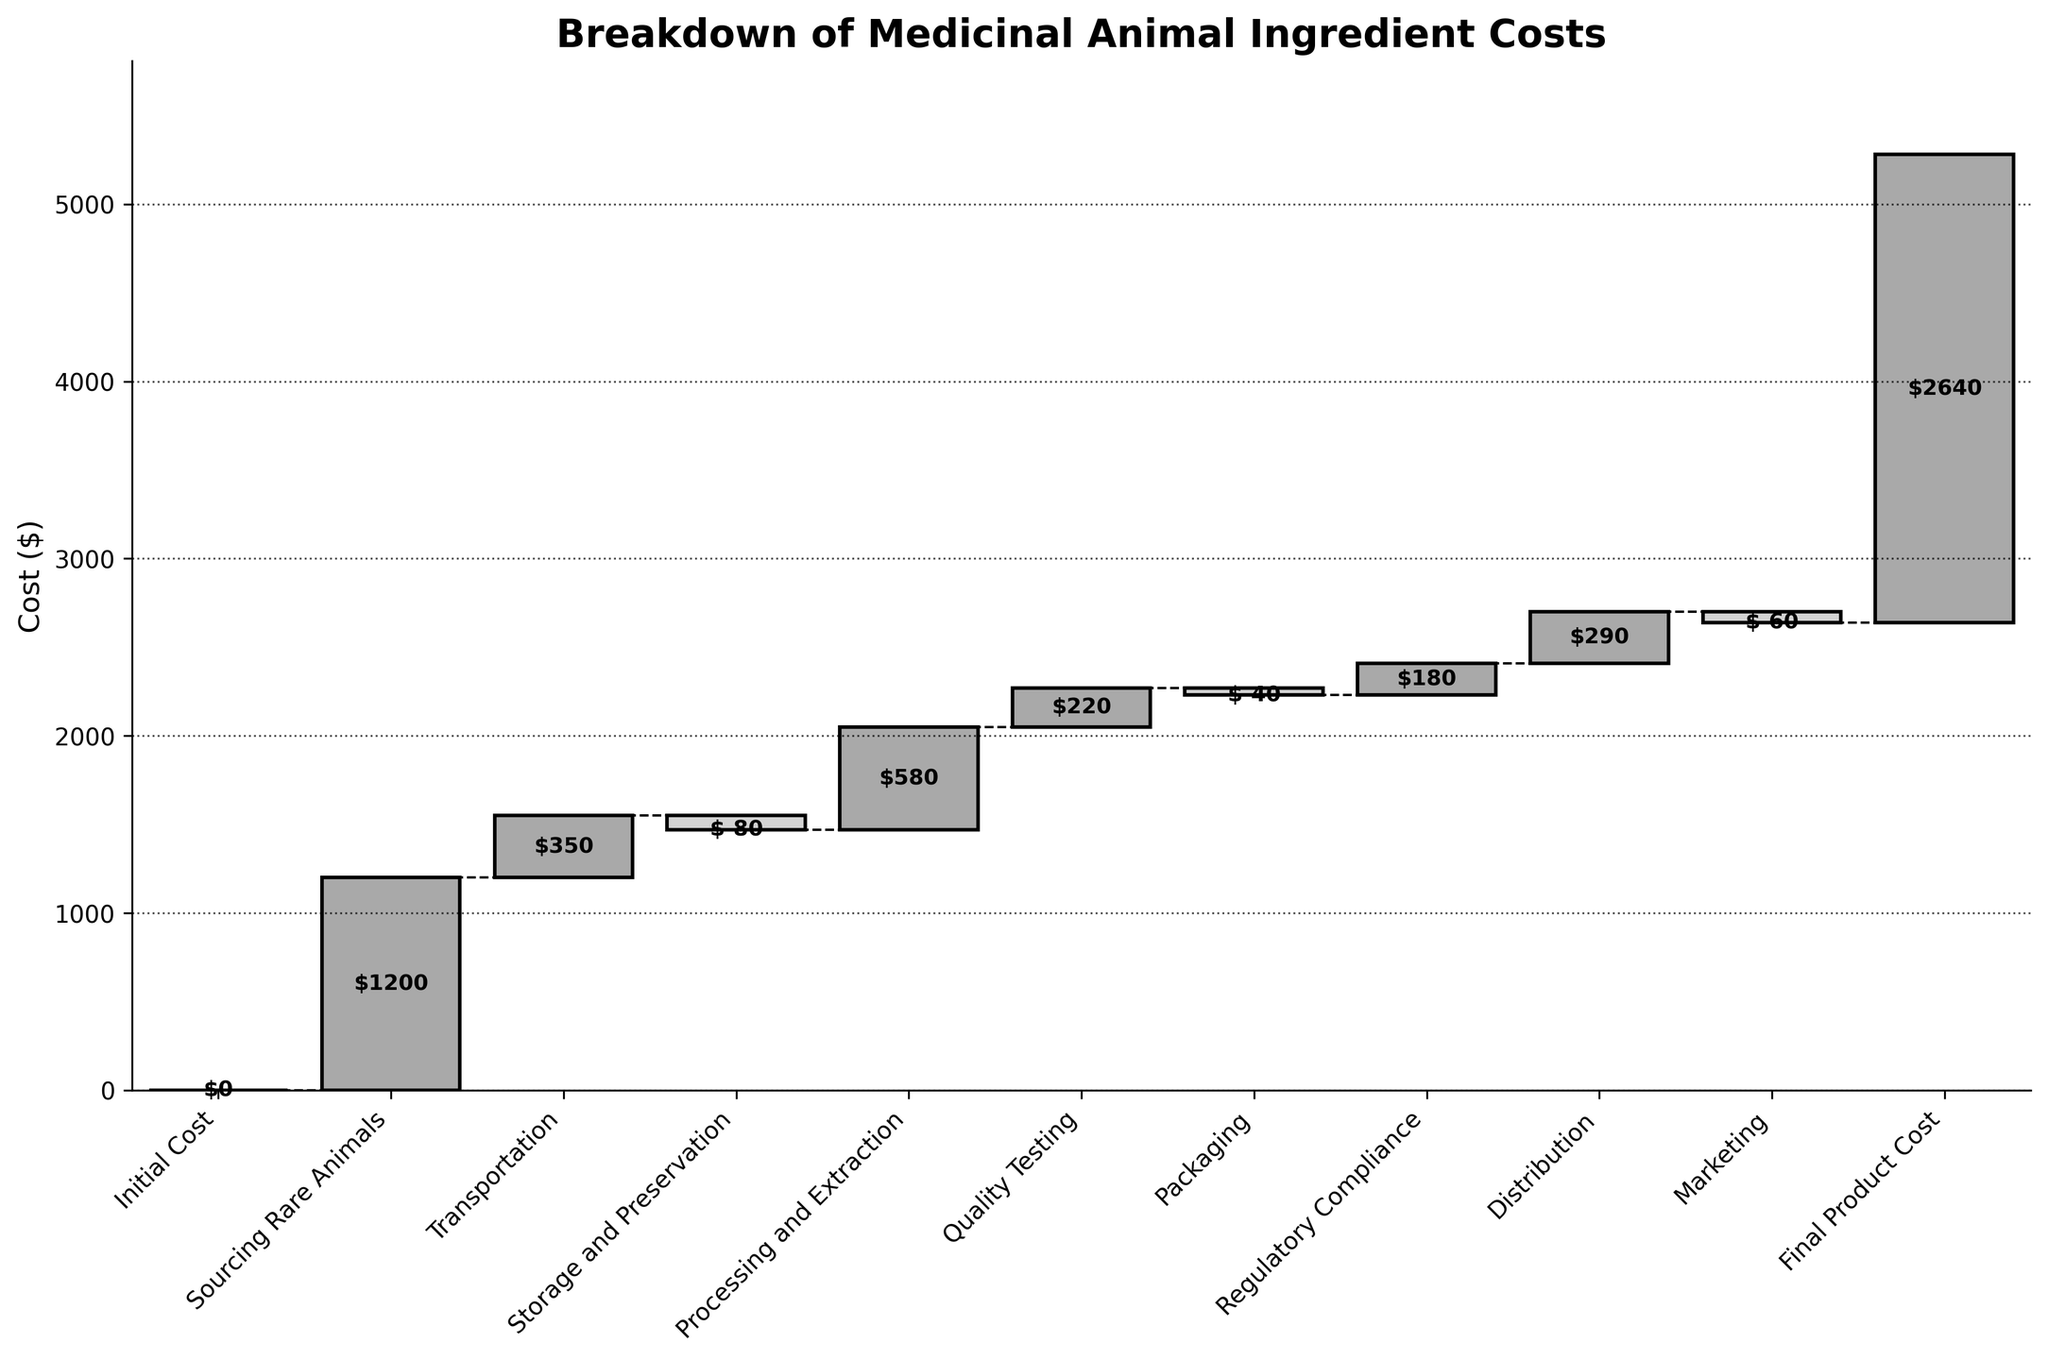What is the title of the chart? The title is written at the top of the chart and reads "Breakdown of Medicinal Animal Ingredient Costs".
Answer: Breakdown of Medicinal Animal Ingredient Costs How many categories are there in the breakdown of costs? By counting the x-axis labels, one can see that there are 10 categories listed.
Answer: 10 Which category has the largest positive contribution to the final product cost? By observing the heights of the bars, "Sourcing Rare Animals" is the highest positive contributor.
Answer: Sourcing Rare Animals What is the cost value for Processing and Extraction? The label on the bar corresponding to "Processing and Extraction" shows $580.
Answer: $580 What is the cumulative cost after Transportation? The value for "Sourcing Rare Animals" is $1200 and "Transportation" is $350; summing these gives $1550.
Answer: $1550 How much does Packaging reduce the cost? The label on the "Packaging" bar shows a value of -$40, indicating a reduction of $40.
Answer: $40 Compare the costs of Quality Testing and Regulatory Compliance, which is higher? The labels indicate "Quality Testing" is $220 and "Regulatory Compliance" is $180; $220 is greater than $180.
Answer: Quality Testing What is the net cost impact of Storage and Preservation? The bar related to "Storage and Preservation" has a value of -$80, indicating the net impact is a reduction of $80.
Answer: -$80 How much does the final product cost in total? The figure is labeled with a cumulative total value next to the "Final Product Cost" bar, which is $2640.
Answer: $2640 What is the difference in cost between Regulatory Compliance and Distribution? "Regulatory Compliance" is $180 and "Distribution" is $290; the difference is 290 - 180 = $110.
Answer: $110 